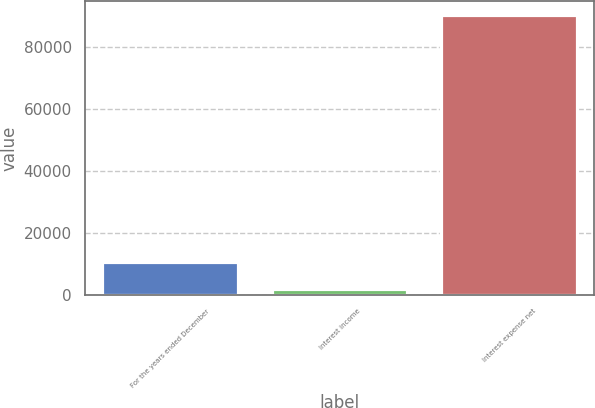<chart> <loc_0><loc_0><loc_500><loc_500><bar_chart><fcel>For the years ended December<fcel>Interest income<fcel>Interest expense net<nl><fcel>10638.8<fcel>1805<fcel>90143<nl></chart> 